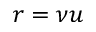Convert formula to latex. <formula><loc_0><loc_0><loc_500><loc_500>r = \nu u</formula> 